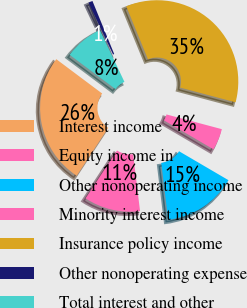Convert chart. <chart><loc_0><loc_0><loc_500><loc_500><pie_chart><fcel>Interest income<fcel>Equity income in<fcel>Other nonoperating income<fcel>Minority interest income<fcel>Insurance policy income<fcel>Other nonoperating expense<fcel>Total interest and other<nl><fcel>25.97%<fcel>11.19%<fcel>14.64%<fcel>4.29%<fcel>35.33%<fcel>0.84%<fcel>7.74%<nl></chart> 